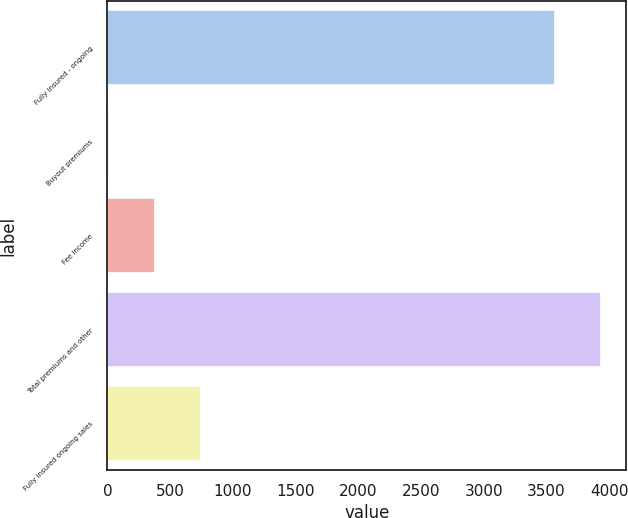Convert chart. <chart><loc_0><loc_0><loc_500><loc_500><bar_chart><fcel>Fully insured - ongoing<fcel>Buyout premiums<fcel>Fee income<fcel>Total premiums and other<fcel>Fully insured ongoing sales<nl><fcel>3571<fcel>15<fcel>381.2<fcel>3937.2<fcel>747.4<nl></chart> 